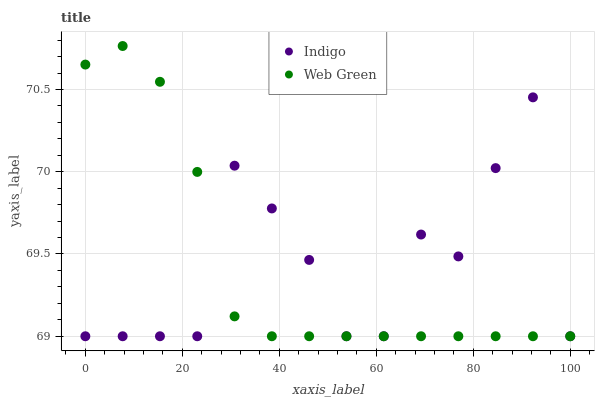Does Web Green have the minimum area under the curve?
Answer yes or no. Yes. Does Indigo have the maximum area under the curve?
Answer yes or no. Yes. Does Web Green have the maximum area under the curve?
Answer yes or no. No. Is Web Green the smoothest?
Answer yes or no. Yes. Is Indigo the roughest?
Answer yes or no. Yes. Is Web Green the roughest?
Answer yes or no. No. Does Indigo have the lowest value?
Answer yes or no. Yes. Does Web Green have the highest value?
Answer yes or no. Yes. Does Indigo intersect Web Green?
Answer yes or no. Yes. Is Indigo less than Web Green?
Answer yes or no. No. Is Indigo greater than Web Green?
Answer yes or no. No. 